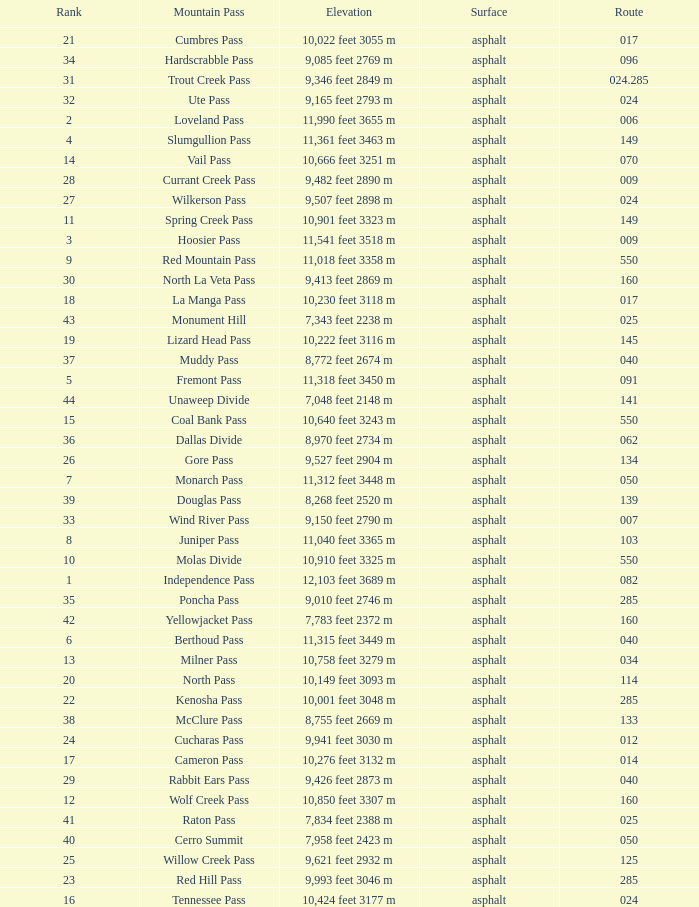Could you parse the entire table? {'header': ['Rank', 'Mountain Pass', 'Elevation', 'Surface', 'Route'], 'rows': [['21', 'Cumbres Pass', '10,022 feet 3055 m', 'asphalt', '017'], ['34', 'Hardscrabble Pass', '9,085 feet 2769 m', 'asphalt', '096'], ['31', 'Trout Creek Pass', '9,346 feet 2849 m', 'asphalt', '024.285'], ['32', 'Ute Pass', '9,165 feet 2793 m', 'asphalt', '024'], ['2', 'Loveland Pass', '11,990 feet 3655 m', 'asphalt', '006'], ['4', 'Slumgullion Pass', '11,361 feet 3463 m', 'asphalt', '149'], ['14', 'Vail Pass', '10,666 feet 3251 m', 'asphalt', '070'], ['28', 'Currant Creek Pass', '9,482 feet 2890 m', 'asphalt', '009'], ['27', 'Wilkerson Pass', '9,507 feet 2898 m', 'asphalt', '024'], ['11', 'Spring Creek Pass', '10,901 feet 3323 m', 'asphalt', '149'], ['3', 'Hoosier Pass', '11,541 feet 3518 m', 'asphalt', '009'], ['9', 'Red Mountain Pass', '11,018 feet 3358 m', 'asphalt', '550'], ['30', 'North La Veta Pass', '9,413 feet 2869 m', 'asphalt', '160'], ['18', 'La Manga Pass', '10,230 feet 3118 m', 'asphalt', '017'], ['43', 'Monument Hill', '7,343 feet 2238 m', 'asphalt', '025'], ['19', 'Lizard Head Pass', '10,222 feet 3116 m', 'asphalt', '145'], ['37', 'Muddy Pass', '8,772 feet 2674 m', 'asphalt', '040'], ['5', 'Fremont Pass', '11,318 feet 3450 m', 'asphalt', '091'], ['44', 'Unaweep Divide', '7,048 feet 2148 m', 'asphalt', '141'], ['15', 'Coal Bank Pass', '10,640 feet 3243 m', 'asphalt', '550'], ['36', 'Dallas Divide', '8,970 feet 2734 m', 'asphalt', '062'], ['26', 'Gore Pass', '9,527 feet 2904 m', 'asphalt', '134'], ['7', 'Monarch Pass', '11,312 feet 3448 m', 'asphalt', '050'], ['39', 'Douglas Pass', '8,268 feet 2520 m', 'asphalt', '139'], ['33', 'Wind River Pass', '9,150 feet 2790 m', 'asphalt', '007'], ['8', 'Juniper Pass', '11,040 feet 3365 m', 'asphalt', '103'], ['10', 'Molas Divide', '10,910 feet 3325 m', 'asphalt', '550'], ['1', 'Independence Pass', '12,103 feet 3689 m', 'asphalt', '082'], ['35', 'Poncha Pass', '9,010 feet 2746 m', 'asphalt', '285'], ['42', 'Yellowjacket Pass', '7,783 feet 2372 m', 'asphalt', '160'], ['6', 'Berthoud Pass', '11,315 feet 3449 m', 'asphalt', '040'], ['13', 'Milner Pass', '10,758 feet 3279 m', 'asphalt', '034'], ['20', 'North Pass', '10,149 feet 3093 m', 'asphalt', '114'], ['22', 'Kenosha Pass', '10,001 feet 3048 m', 'asphalt', '285'], ['38', 'McClure Pass', '8,755 feet 2669 m', 'asphalt', '133'], ['24', 'Cucharas Pass', '9,941 feet 3030 m', 'asphalt', '012'], ['17', 'Cameron Pass', '10,276 feet 3132 m', 'asphalt', '014'], ['29', 'Rabbit Ears Pass', '9,426 feet 2873 m', 'asphalt', '040'], ['12', 'Wolf Creek Pass', '10,850 feet 3307 m', 'asphalt', '160'], ['41', 'Raton Pass', '7,834 feet 2388 m', 'asphalt', '025'], ['40', 'Cerro Summit', '7,958 feet 2423 m', 'asphalt', '050'], ['25', 'Willow Creek Pass', '9,621 feet 2932 m', 'asphalt', '125'], ['23', 'Red Hill Pass', '9,993 feet 3046 m', 'asphalt', '285'], ['16', 'Tennessee Pass', '10,424 feet 3177 m', 'asphalt', '024']]} What is the Mountain Pass with a 21 Rank? Cumbres Pass. 